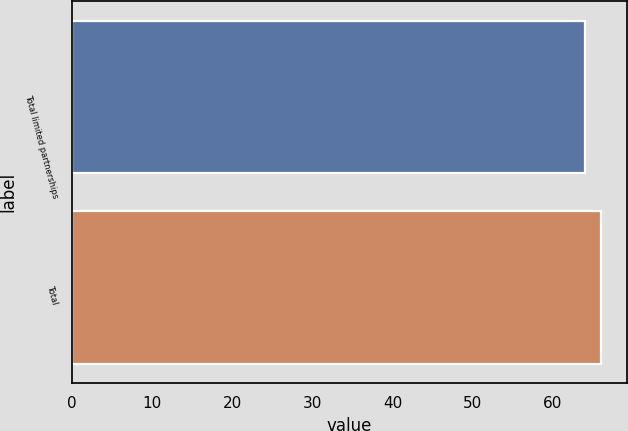Convert chart. <chart><loc_0><loc_0><loc_500><loc_500><bar_chart><fcel>Total limited partnerships<fcel>Total<nl><fcel>64<fcel>66<nl></chart> 